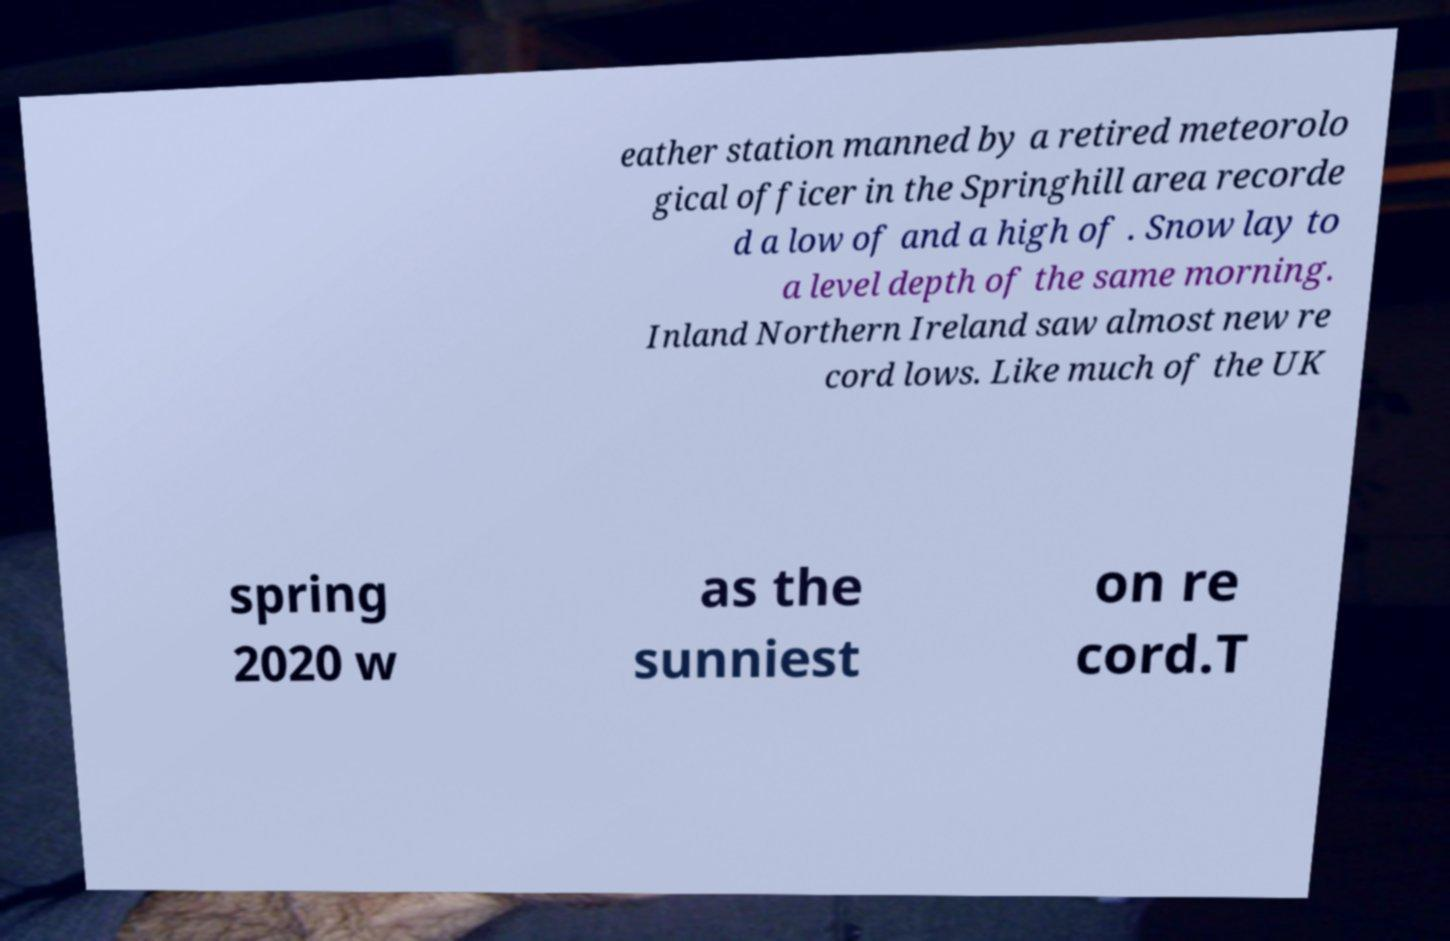Could you assist in decoding the text presented in this image and type it out clearly? eather station manned by a retired meteorolo gical officer in the Springhill area recorde d a low of and a high of . Snow lay to a level depth of the same morning. Inland Northern Ireland saw almost new re cord lows. Like much of the UK spring 2020 w as the sunniest on re cord.T 